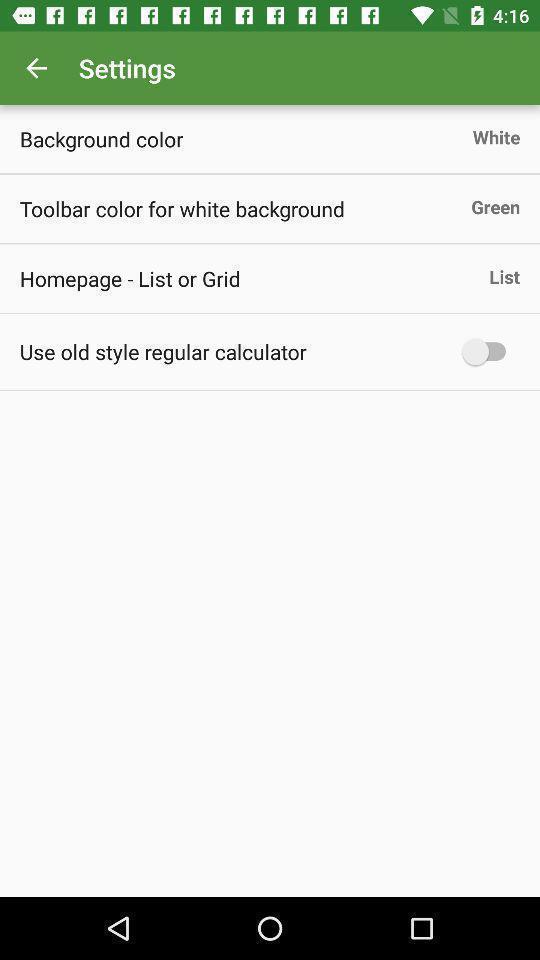Summarize the information in this screenshot. Settings page displayed. 